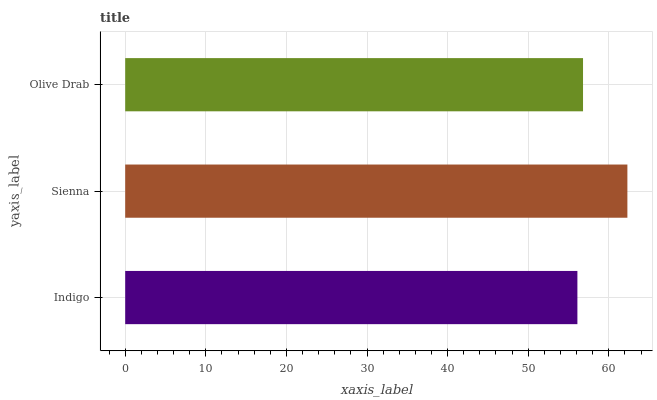Is Indigo the minimum?
Answer yes or no. Yes. Is Sienna the maximum?
Answer yes or no. Yes. Is Olive Drab the minimum?
Answer yes or no. No. Is Olive Drab the maximum?
Answer yes or no. No. Is Sienna greater than Olive Drab?
Answer yes or no. Yes. Is Olive Drab less than Sienna?
Answer yes or no. Yes. Is Olive Drab greater than Sienna?
Answer yes or no. No. Is Sienna less than Olive Drab?
Answer yes or no. No. Is Olive Drab the high median?
Answer yes or no. Yes. Is Olive Drab the low median?
Answer yes or no. Yes. Is Sienna the high median?
Answer yes or no. No. Is Indigo the low median?
Answer yes or no. No. 